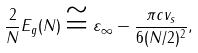<formula> <loc_0><loc_0><loc_500><loc_500>\frac { 2 } { N } E _ { g } ( N ) \cong \varepsilon _ { \infty } - \frac { \pi c v _ { s } } { 6 ( N / 2 ) ^ { 2 } } ,</formula> 